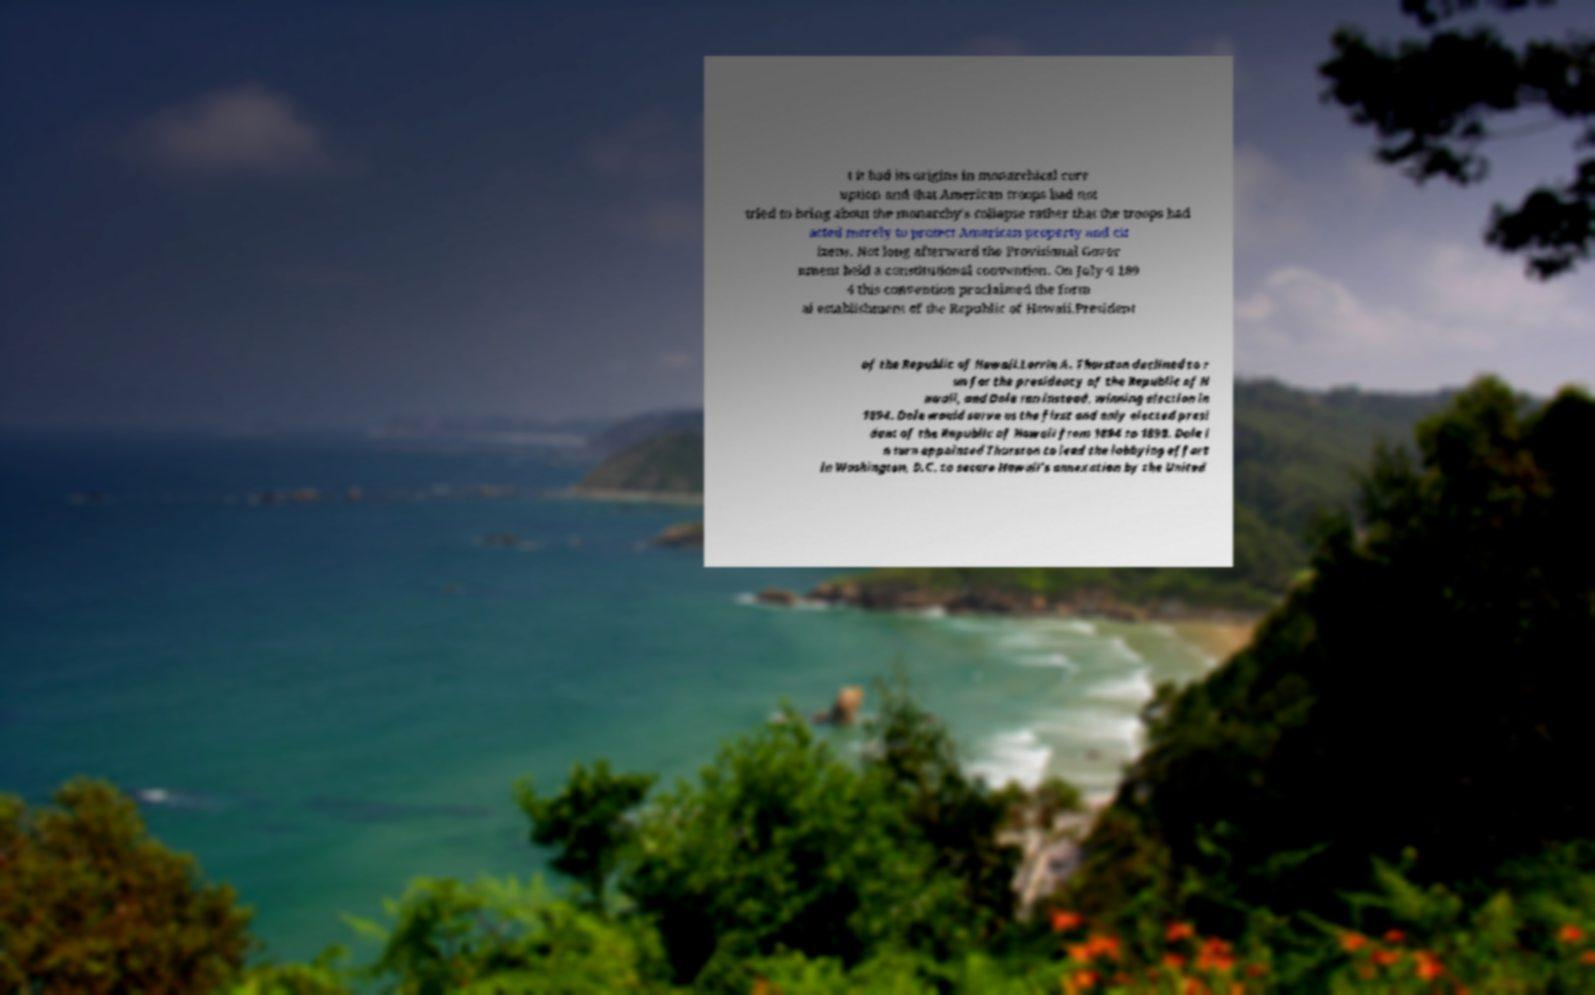I need the written content from this picture converted into text. Can you do that? t it had its origins in monarchical corr uption and that American troops had not tried to bring about the monarchy's collapse rather that the troops had acted merely to protect American property and cit izens. Not long afterward the Provisional Gover nment held a constitutional convention. On July 4 189 4 this convention proclaimed the form al establishment of the Republic of Hawaii.President of the Republic of Hawaii.Lorrin A. Thurston declined to r un for the presidency of the Republic of H awaii, and Dole ran instead, winning election in 1894. Dole would serve as the first and only elected presi dent of the Republic of Hawaii from 1894 to 1898. Dole i n turn appointed Thurston to lead the lobbying effort in Washington, D.C. to secure Hawaii's annexation by the United 